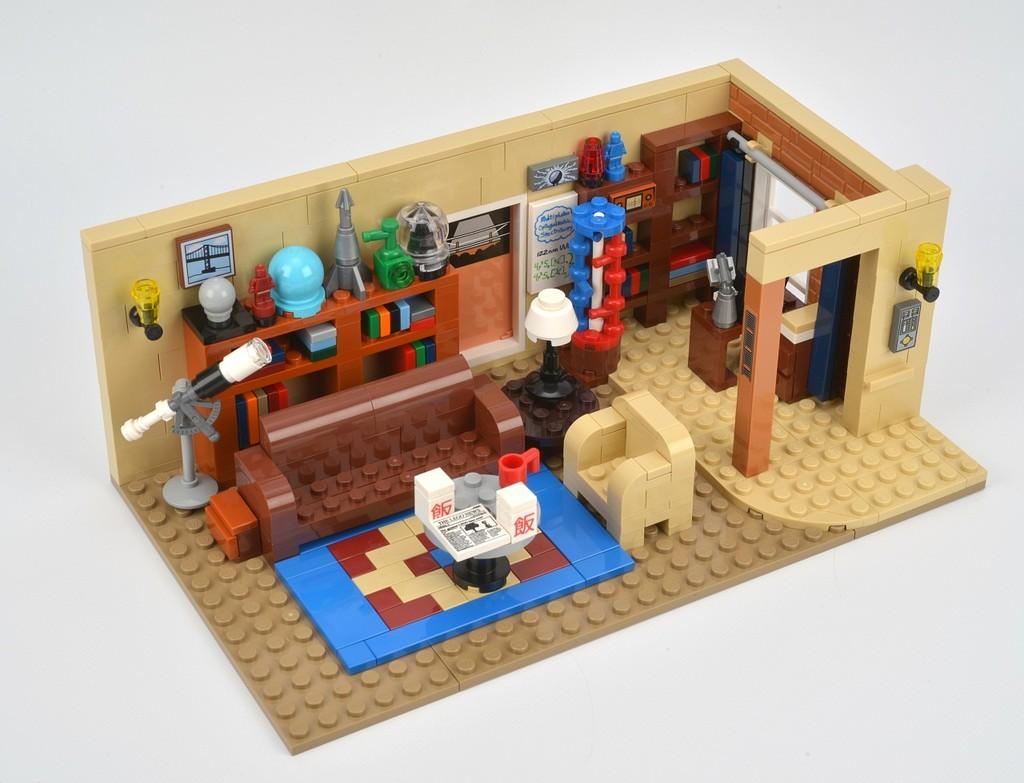What is the main subject of the image? The main subject of the image is a miniature. What material was used to create the miniature? The miniature is created using building blocks. Is there a beggar asking for donations in the image? No, there is no beggar present in the image. Is the creator of the miniature visible in the image? No, the creator of the miniature is not visible in the image. Is the miniature located on an island in the image? No, the miniature is not located on an island in the image. 